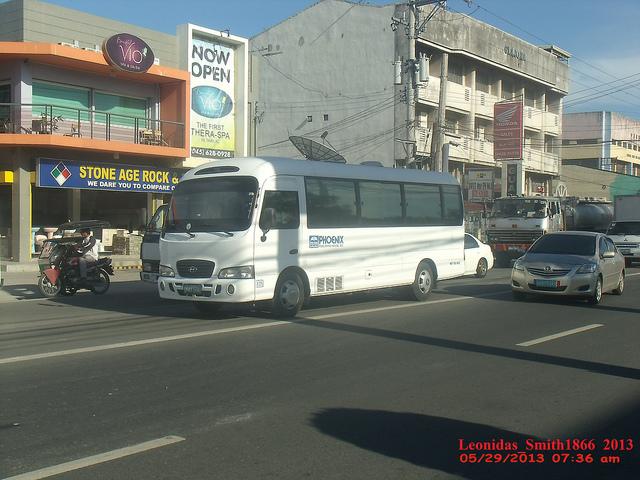What color is the bus?
Keep it brief. White. Where is the bus going?
Short answer required. Left. Is it a cloudy day?
Answer briefly. No. 